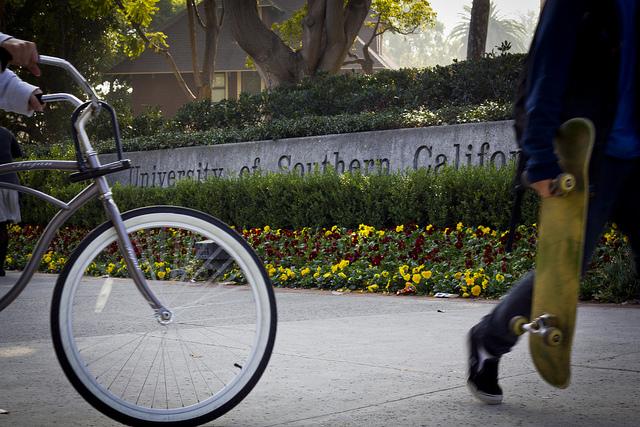What color is the bike?
Quick response, please. Gray. What relationship do these people probably have with this location?
Give a very brief answer. Students. Are there flowers visible?
Give a very brief answer. Yes. Where are these people?
Give a very brief answer. University of southern california. 